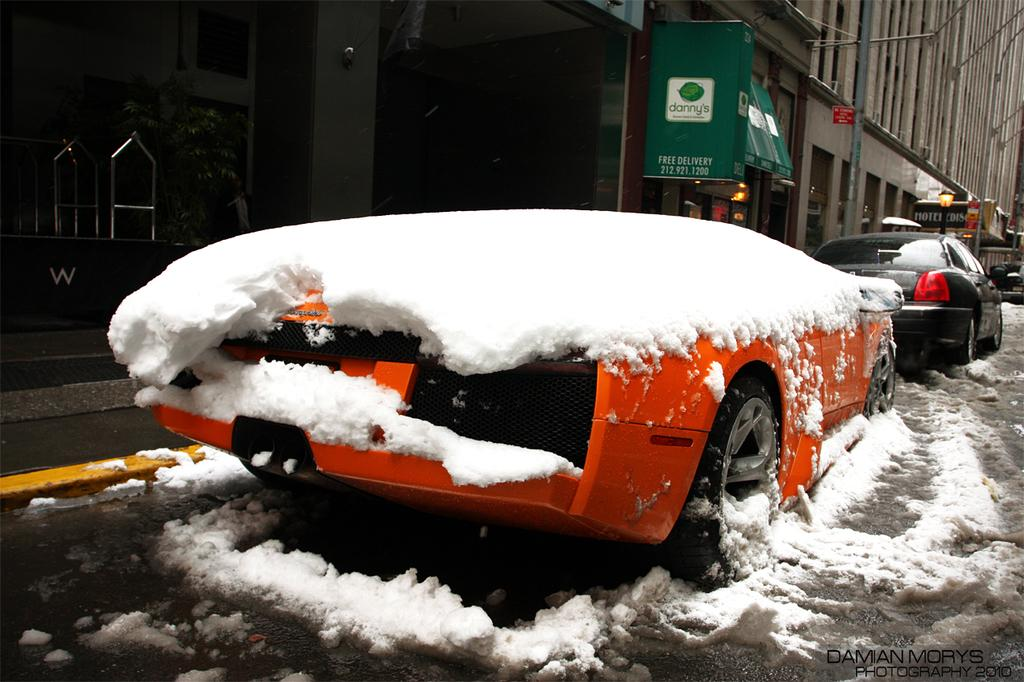What can be seen on the road in the image? There are vehicles on the road in the image. What is the condition of the ground in the image? There is snow on the ground in the image. What is visible in the background of the image? There are buildings in the background of the image. Can you describe the zephyr blowing through the park in the image? There is no park or zephyr present in the image; it features vehicles on a snowy road with buildings in the background. 